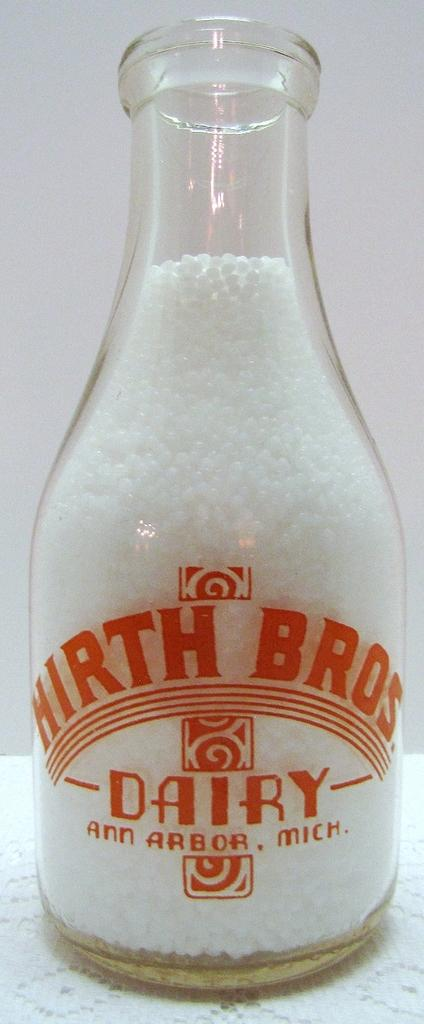What object can be seen in the image? There is a bottle in the image. What is written on the bottle? The bottle has "Bros Dairy" written on it. What is inside the bottle? The bottle contains something inside it. How many kittens are playing in the bucket in the image? There is no bucket or kittens present in the image. 